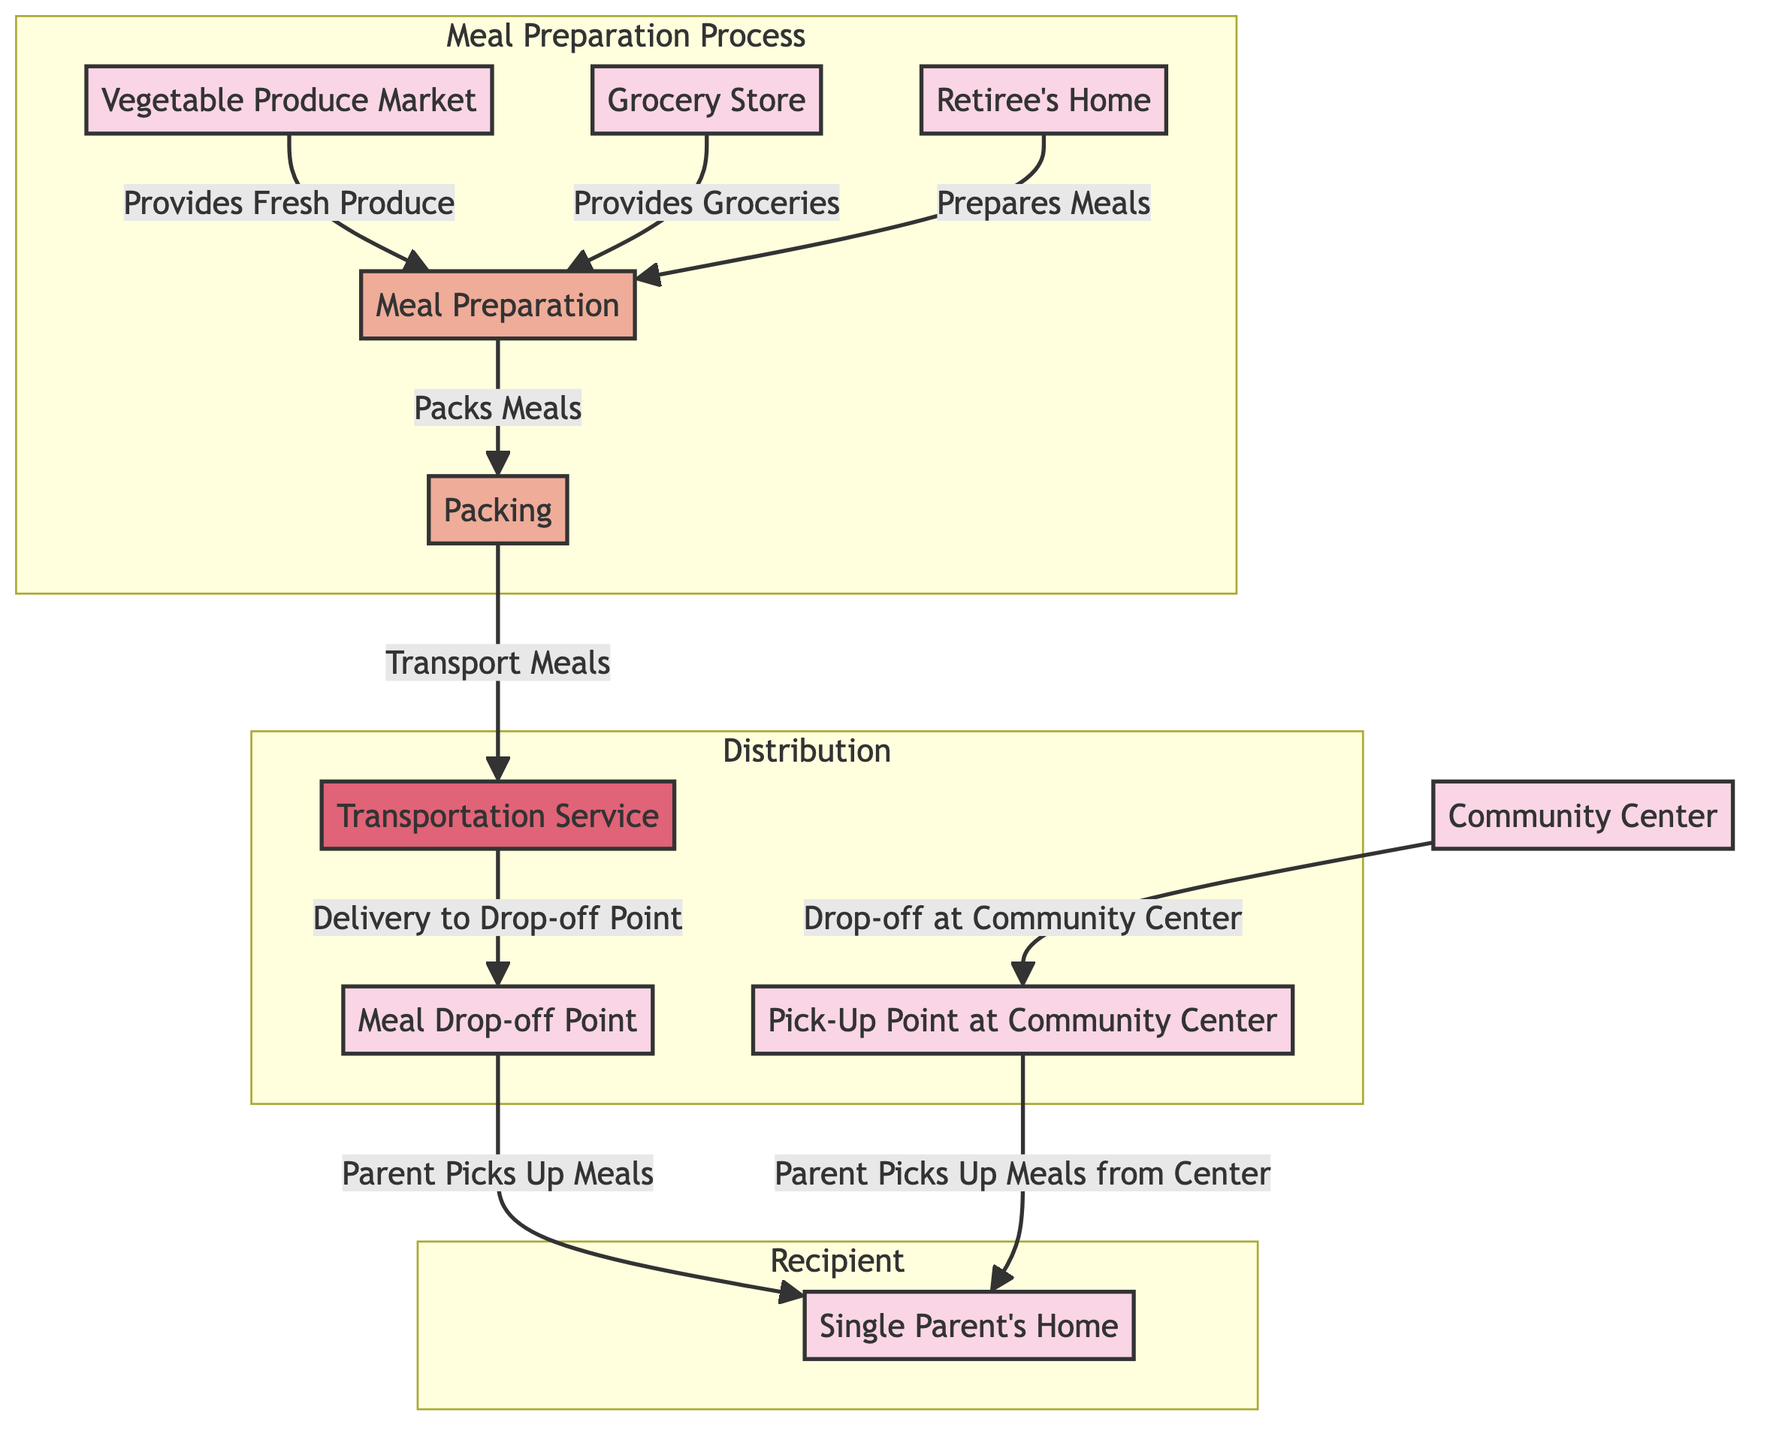What is the last location where meals are picked up? The last location in the flow for picking up meals is the "Single Parent's Home." Following the edges in the diagram, the parent collects meals from the "Meal Drop-off Point" and from the "Pick-Up Point at Community Center," both leading to the single parent's home.
Answer: Single Parent's Home How many locations are in the diagram? The diagram includes a total of five locations: "Retiree's Home," "Single Parent's Home," "Grocery Store," "Community Center," "Vegetable Produce Market." Counting these distinct nodes gives us the total.
Answer: Five Which activity follows meal preparation? After the "Meal Preparation" activity, the next activity is "Packing." The edge from the "Meal Preparation" node to the "Packing" node indicates this sequential relationship.
Answer: Packing What service is used to transport meals? The service used to transport meals is "Transportation Service." The arrow leading from "Packing" to "Transportation Service" shows this transfer.
Answer: Transportation Service Which location provides fresh produce? The location that provides fresh produce is the "Vegetable Produce Market." There is a directed edge indicating that fresh produce flows from this market to the meal preparation activity.
Answer: Vegetable Produce Market What two locations allow the parent to pick up meals? The two locations where the parent can pick up meals are the "Meal Drop-off Point" and the "Pick-Up Point at Community Center." Both locations lead to the "Single Parent's Home."
Answer: Meal Drop-off Point, Pick-Up Point at Community Center How many activities are involved in the meal preparation process? There are three activities involved in the meal preparation process: "Meal Preparation," "Packing," and "Transportation Service." Analyzing the connections within the subgraph for meal preparation shows these activities linked together.
Answer: Three What is the connection between the Community Center and the Single Parent's Home? The connection is through the "Pick-Up Point at Community Center," where meals are dropped off and subsequently picked up by the parent at their home. This represents the flow from the community center to the parent's residence.
Answer: Meals picked up from Community Center 